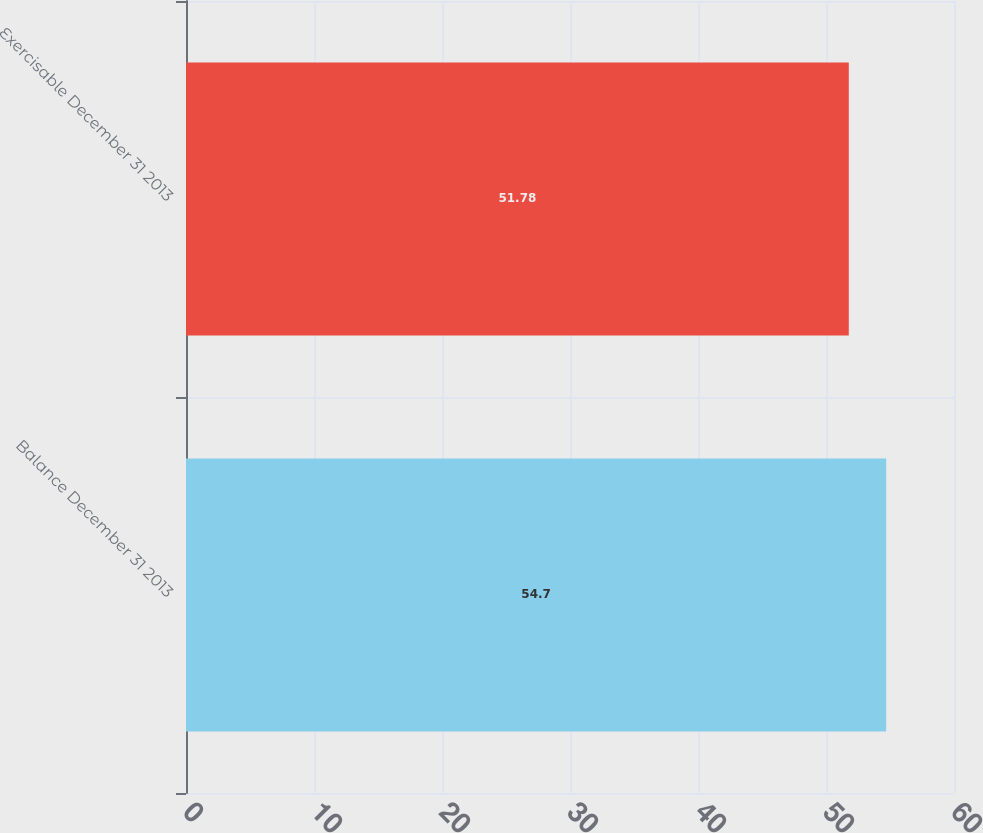<chart> <loc_0><loc_0><loc_500><loc_500><bar_chart><fcel>Balance December 31 2013<fcel>Exercisable December 31 2013<nl><fcel>54.7<fcel>51.78<nl></chart> 